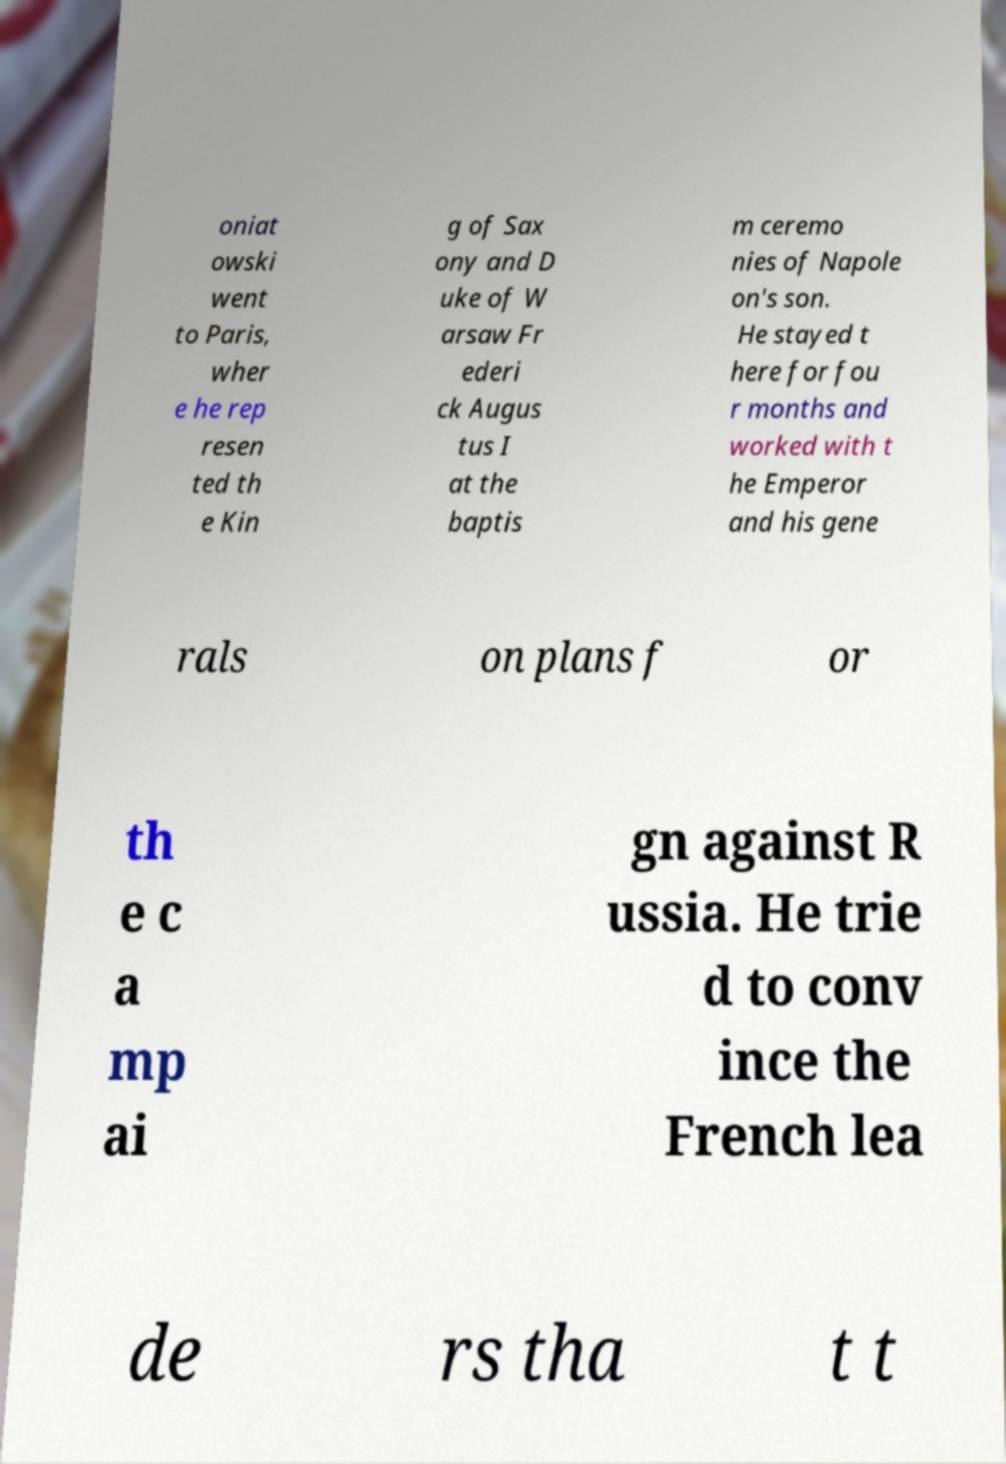Could you extract and type out the text from this image? oniat owski went to Paris, wher e he rep resen ted th e Kin g of Sax ony and D uke of W arsaw Fr ederi ck Augus tus I at the baptis m ceremo nies of Napole on's son. He stayed t here for fou r months and worked with t he Emperor and his gene rals on plans f or th e c a mp ai gn against R ussia. He trie d to conv ince the French lea de rs tha t t 